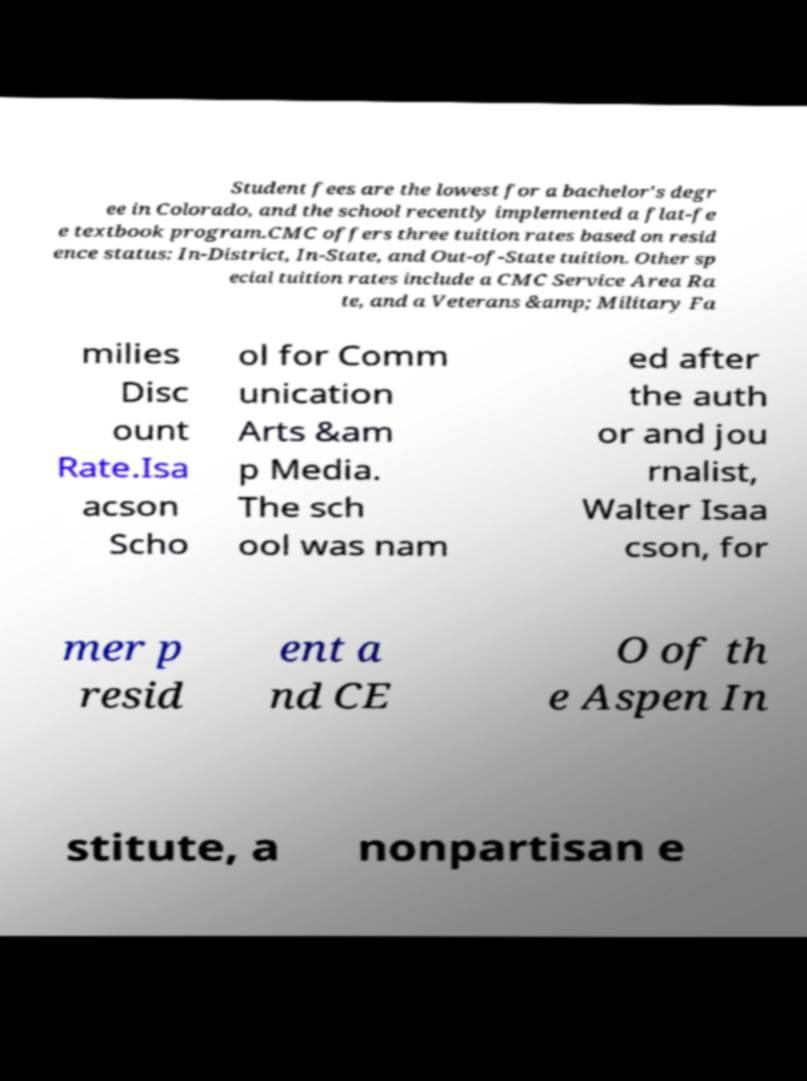Could you assist in decoding the text presented in this image and type it out clearly? Student fees are the lowest for a bachelor's degr ee in Colorado, and the school recently implemented a flat-fe e textbook program.CMC offers three tuition rates based on resid ence status: In-District, In-State, and Out-of-State tuition. Other sp ecial tuition rates include a CMC Service Area Ra te, and a Veterans &amp; Military Fa milies Disc ount Rate.Isa acson Scho ol for Comm unication Arts &am p Media. The sch ool was nam ed after the auth or and jou rnalist, Walter Isaa cson, for mer p resid ent a nd CE O of th e Aspen In stitute, a nonpartisan e 